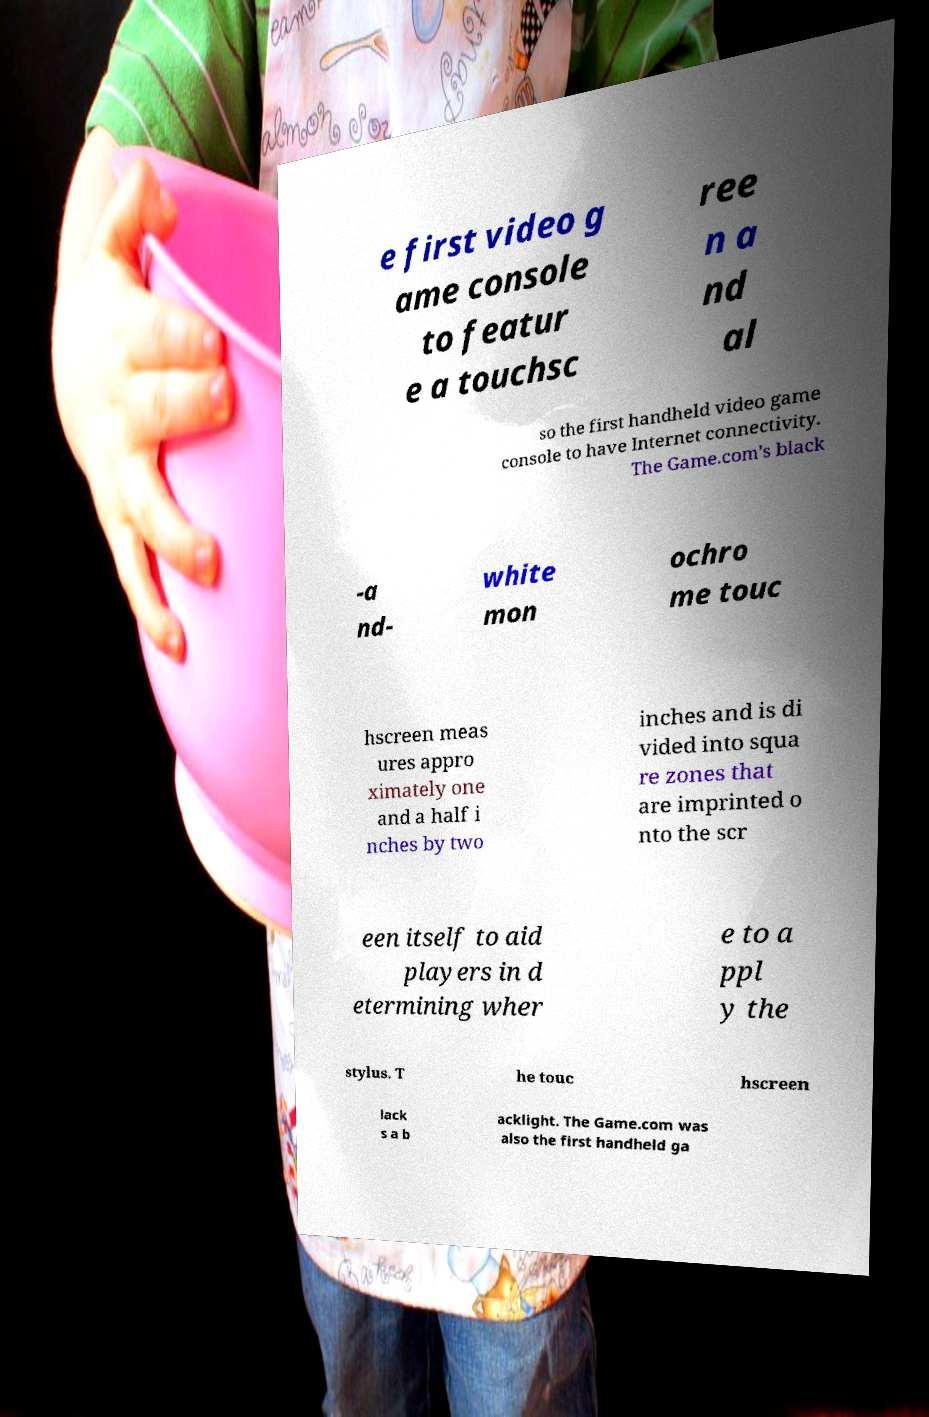Could you extract and type out the text from this image? e first video g ame console to featur e a touchsc ree n a nd al so the first handheld video game console to have Internet connectivity. The Game.com's black -a nd- white mon ochro me touc hscreen meas ures appro ximately one and a half i nches by two inches and is di vided into squa re zones that are imprinted o nto the scr een itself to aid players in d etermining wher e to a ppl y the stylus. T he touc hscreen lack s a b acklight. The Game.com was also the first handheld ga 